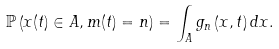<formula> <loc_0><loc_0><loc_500><loc_500>\mathbb { P } \left ( x ( t ) \in A , m ( t ) = n \right ) = \int _ { A } g _ { n } \left ( x , t \right ) d x .</formula> 